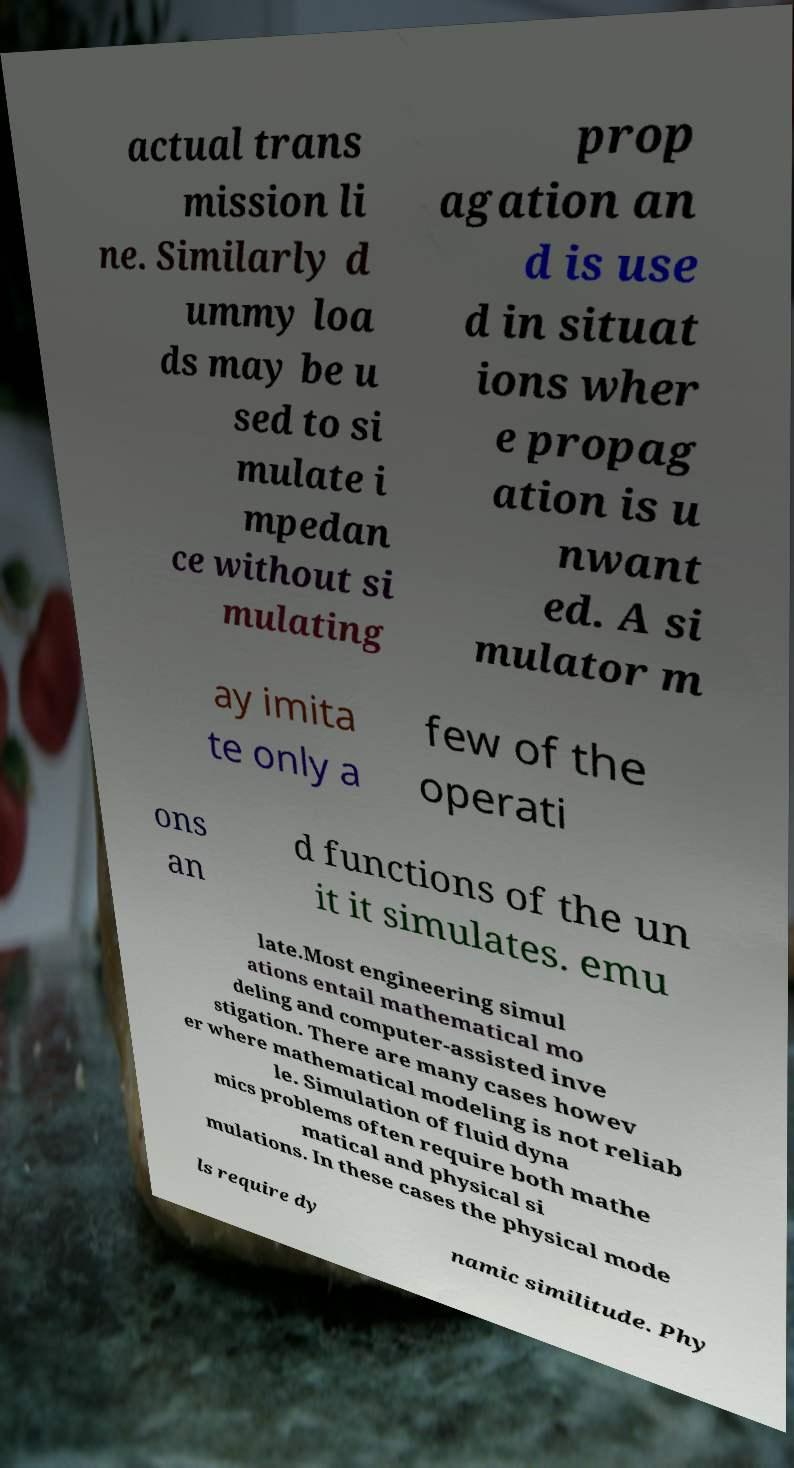Please read and relay the text visible in this image. What does it say? actual trans mission li ne. Similarly d ummy loa ds may be u sed to si mulate i mpedan ce without si mulating prop agation an d is use d in situat ions wher e propag ation is u nwant ed. A si mulator m ay imita te only a few of the operati ons an d functions of the un it it simulates. emu late.Most engineering simul ations entail mathematical mo deling and computer-assisted inve stigation. There are many cases howev er where mathematical modeling is not reliab le. Simulation of fluid dyna mics problems often require both mathe matical and physical si mulations. In these cases the physical mode ls require dy namic similitude. Phy 